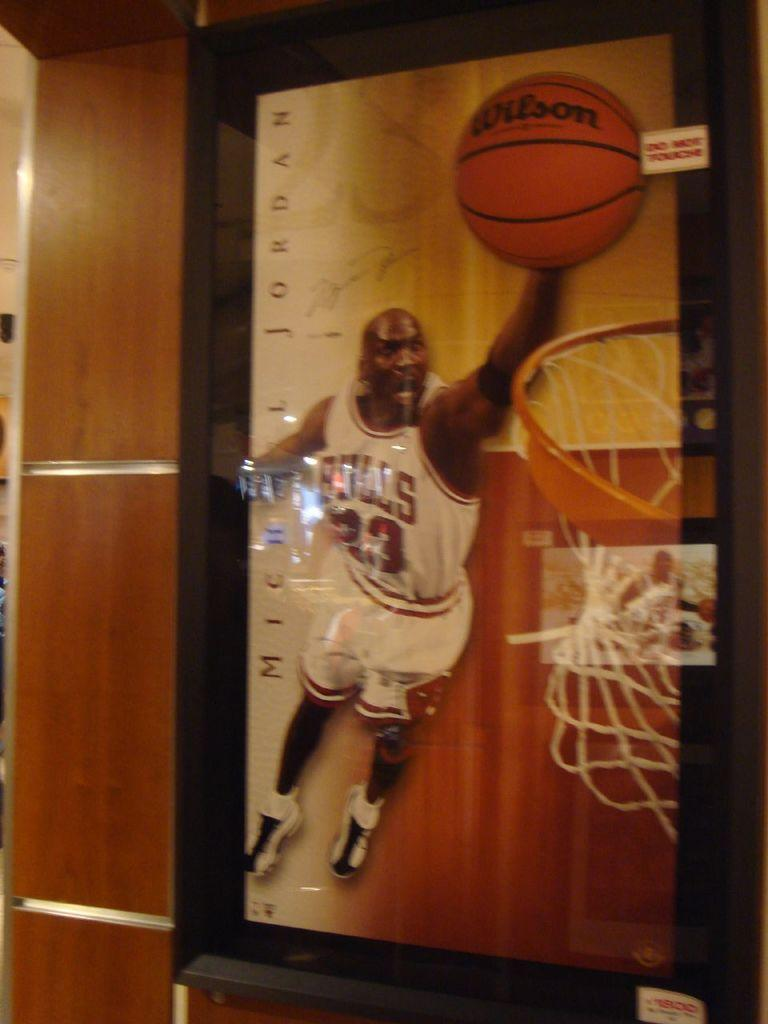Provide a one-sentence caption for the provided image. A poster of Michael Jordan making a basket with a Wilson basketball. 